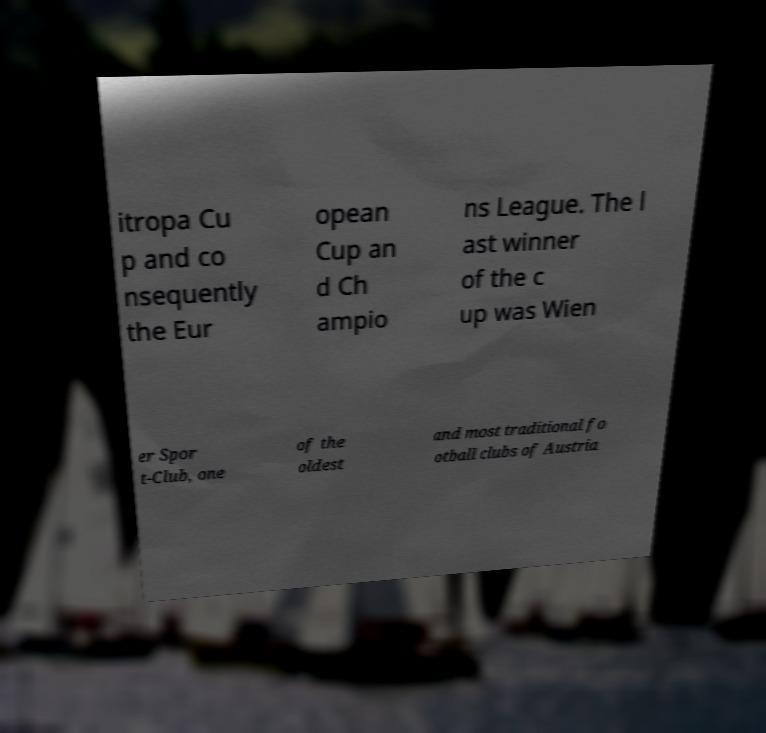Could you extract and type out the text from this image? itropa Cu p and co nsequently the Eur opean Cup an d Ch ampio ns League. The l ast winner of the c up was Wien er Spor t-Club, one of the oldest and most traditional fo otball clubs of Austria 